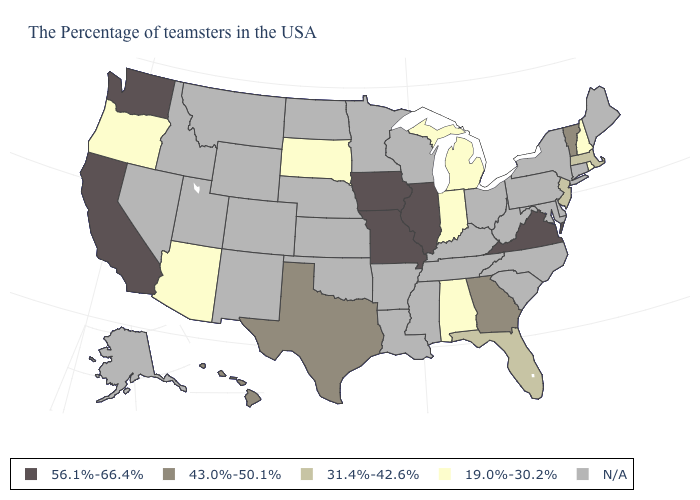Does Michigan have the lowest value in the MidWest?
Give a very brief answer. Yes. What is the value of Vermont?
Short answer required. 43.0%-50.1%. What is the value of North Carolina?
Be succinct. N/A. What is the lowest value in the MidWest?
Answer briefly. 19.0%-30.2%. What is the highest value in the South ?
Quick response, please. 56.1%-66.4%. Name the states that have a value in the range N/A?
Quick response, please. Maine, Connecticut, New York, Delaware, Maryland, Pennsylvania, North Carolina, South Carolina, West Virginia, Ohio, Kentucky, Tennessee, Wisconsin, Mississippi, Louisiana, Arkansas, Minnesota, Kansas, Nebraska, Oklahoma, North Dakota, Wyoming, Colorado, New Mexico, Utah, Montana, Idaho, Nevada, Alaska. Which states have the lowest value in the USA?
Write a very short answer. Rhode Island, New Hampshire, Michigan, Indiana, Alabama, South Dakota, Arizona, Oregon. Does Vermont have the highest value in the Northeast?
Give a very brief answer. Yes. What is the value of California?
Short answer required. 56.1%-66.4%. What is the value of Nebraska?
Give a very brief answer. N/A. What is the value of Maine?
Concise answer only. N/A. What is the value of Oklahoma?
Answer briefly. N/A. 